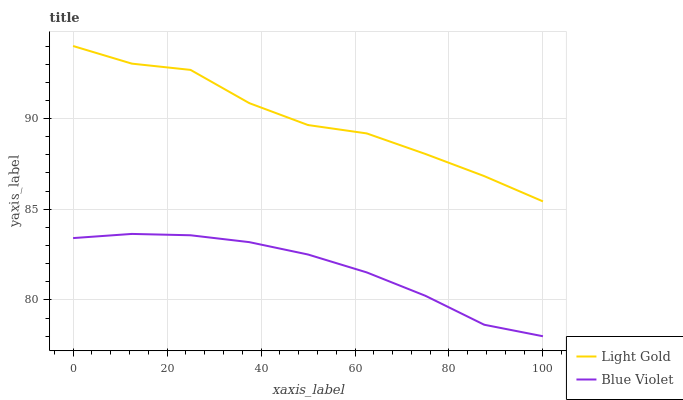Does Blue Violet have the minimum area under the curve?
Answer yes or no. Yes. Does Light Gold have the maximum area under the curve?
Answer yes or no. Yes. Does Blue Violet have the maximum area under the curve?
Answer yes or no. No. Is Blue Violet the smoothest?
Answer yes or no. Yes. Is Light Gold the roughest?
Answer yes or no. Yes. Is Blue Violet the roughest?
Answer yes or no. No. Does Blue Violet have the lowest value?
Answer yes or no. Yes. Does Light Gold have the highest value?
Answer yes or no. Yes. Does Blue Violet have the highest value?
Answer yes or no. No. Is Blue Violet less than Light Gold?
Answer yes or no. Yes. Is Light Gold greater than Blue Violet?
Answer yes or no. Yes. Does Blue Violet intersect Light Gold?
Answer yes or no. No. 